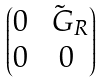Convert formula to latex. <formula><loc_0><loc_0><loc_500><loc_500>\begin{pmatrix} 0 & \tilde { \ G } _ { R } \\ 0 & 0 \end{pmatrix}</formula> 